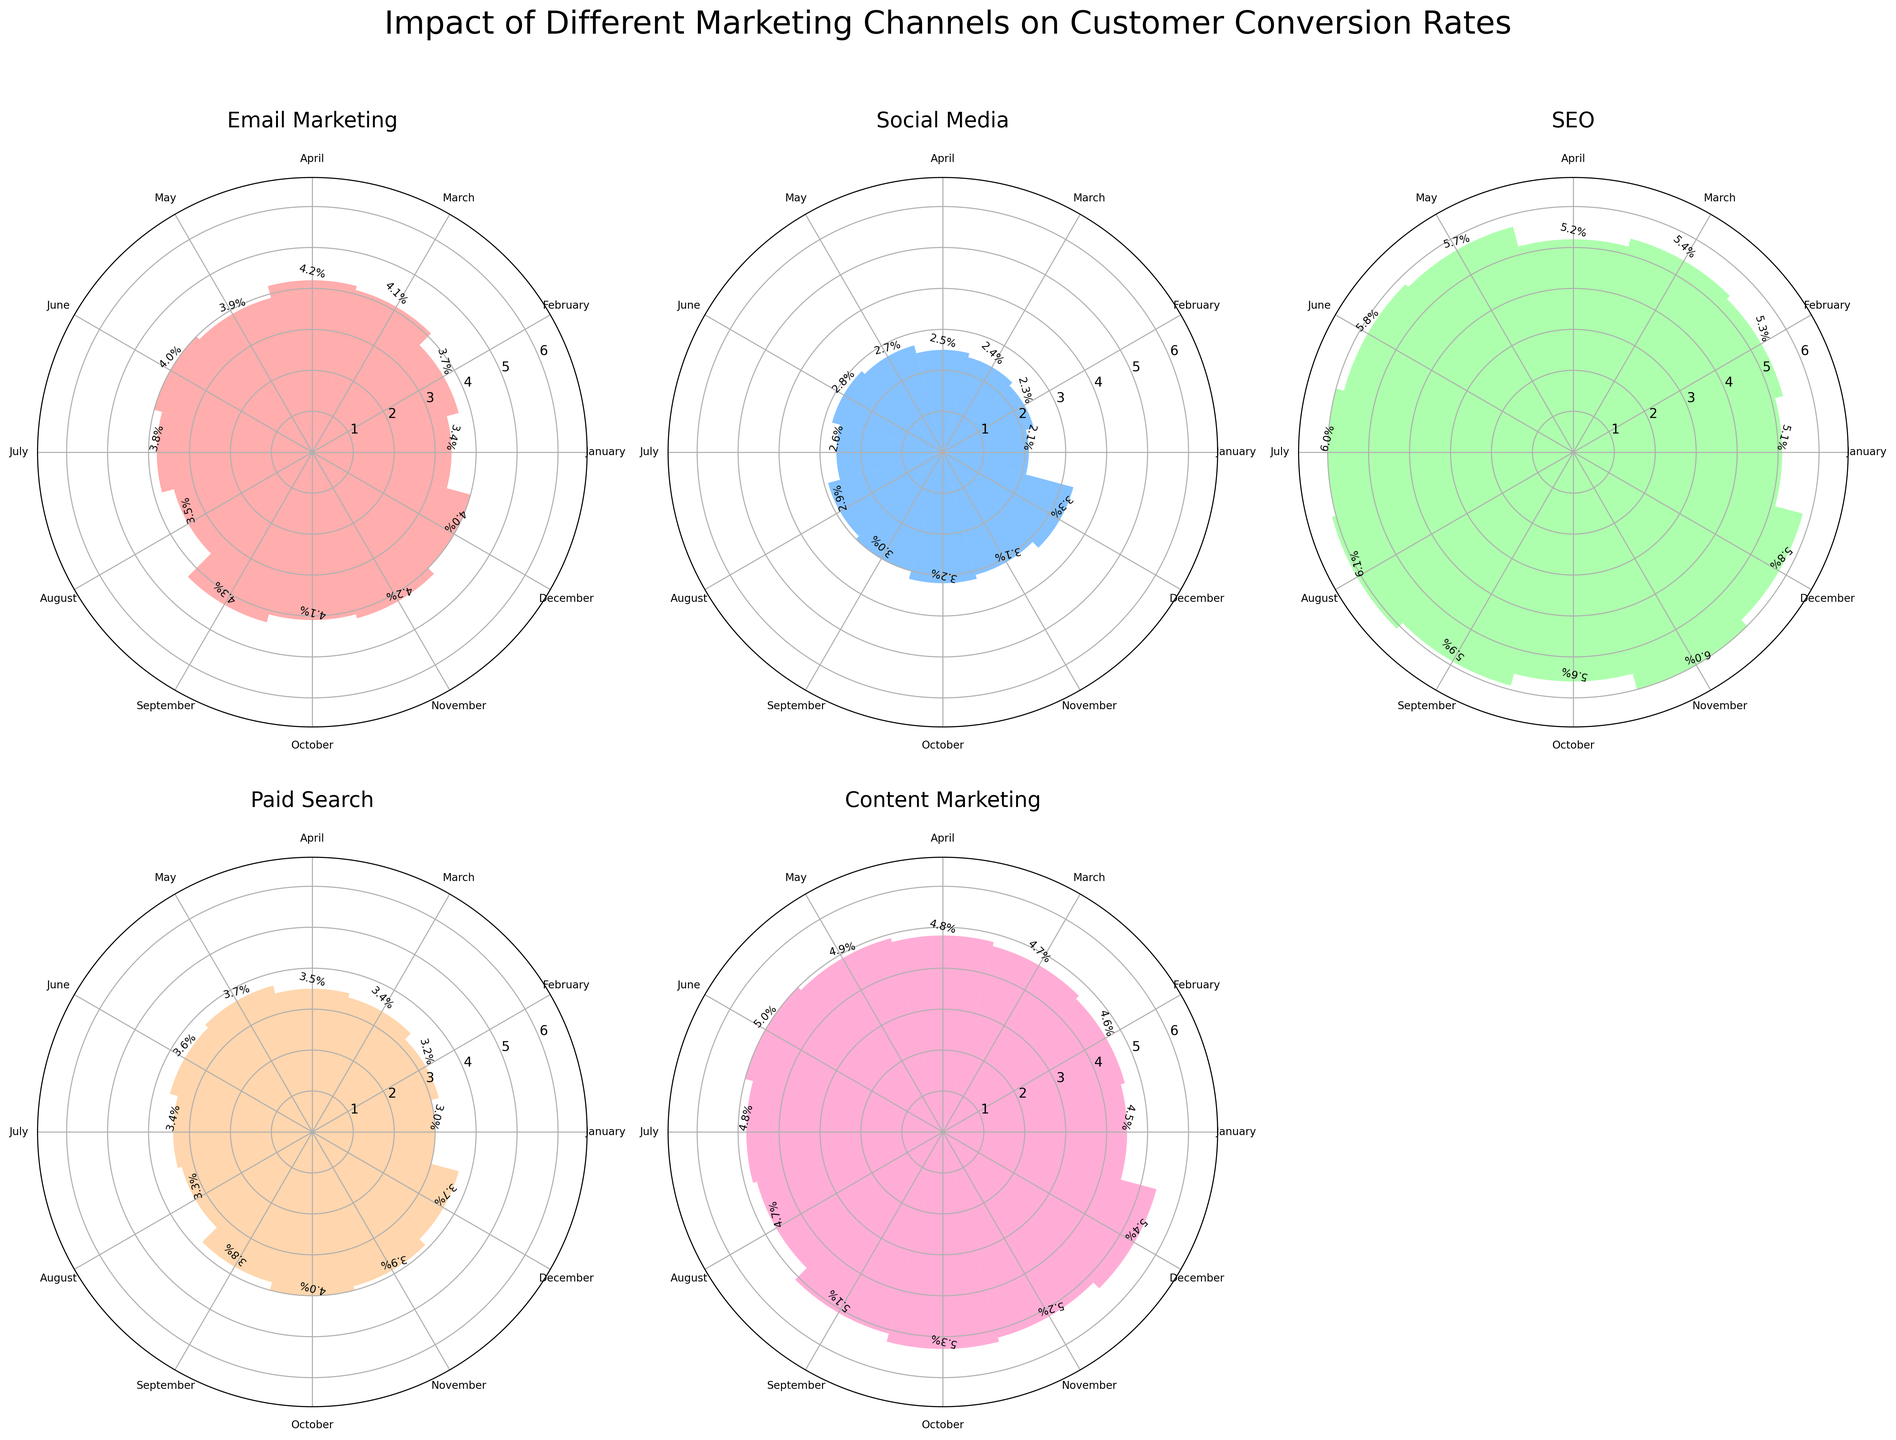How many marketing channels are compared in the figure? Each subplot corresponds to a different marketing channel. By counting the different subplots, we can see there are five marketing channels being compared.
Answer: Five Which month has the highest conversion rate for Email Marketing? In the Email Marketing subplot, check the value represented by the tallest bar and refer to the corresponding month. The tallest bar is in September, showing a conversion rate of 4.3%.
Answer: September Which marketing channel shows the most significant increase in conversion rate from January to December? To find which marketing channel has the most significant increase, compare the differences in conversion rates between January and December for all channels. SEO shows an increase from 5.1% in January to 5.8% in December, which is a change of 0.7, higher than others.
Answer: SEO During which month does Content Marketing have the highest conversion rate? For Content Marketing, observe the highest bar in the corresponding subplot and identify the month labeled. The highest bar is in December, showing a conversion rate of 5.4%.
Answer: December Between Paid Search and Social Media, which has higher overall conversion rates throughout the year? Compare the heights of the bars across the months for both Paid Search and Social Media subplots. Paid Search consistently has higher values compared to Social Media across most months.
Answer: Paid Search What is the average conversion rate for Social Media over the year? Sum the conversion rates for Social Media across all months and divide by 12. The rates are: 2.1 + 2.3 + 2.4 + 2.5 + 2.7 + 2.8 + 2.6 + 2.9 + 3.0 + 3.2 + 3.1 + 3.3 = 34.9. The average is 34.9 / 12 = 2.908.
Answer: 2.9 Which marketing channel has the highest peak conversion rate and what is its value? Identify the highest single value among all subplots. SEO has the highest peak conversion rate at 6.1% in August.
Answer: SEO, 6.1% Did any marketing channel show a decline in conversion rates from September to October? Compare the conversion rates of each channel from September to October to check for any decreases. SEO shows a decline from 5.9% to 5.6%.
Answer: SEO Which marketing channel had consistent conversion rates, without significant dips or spikes? Look for the subplot where the bars are relatively of the same height. Email Marketing has relatively consistent rates with no major dips or spikes.
Answer: Email Marketing 